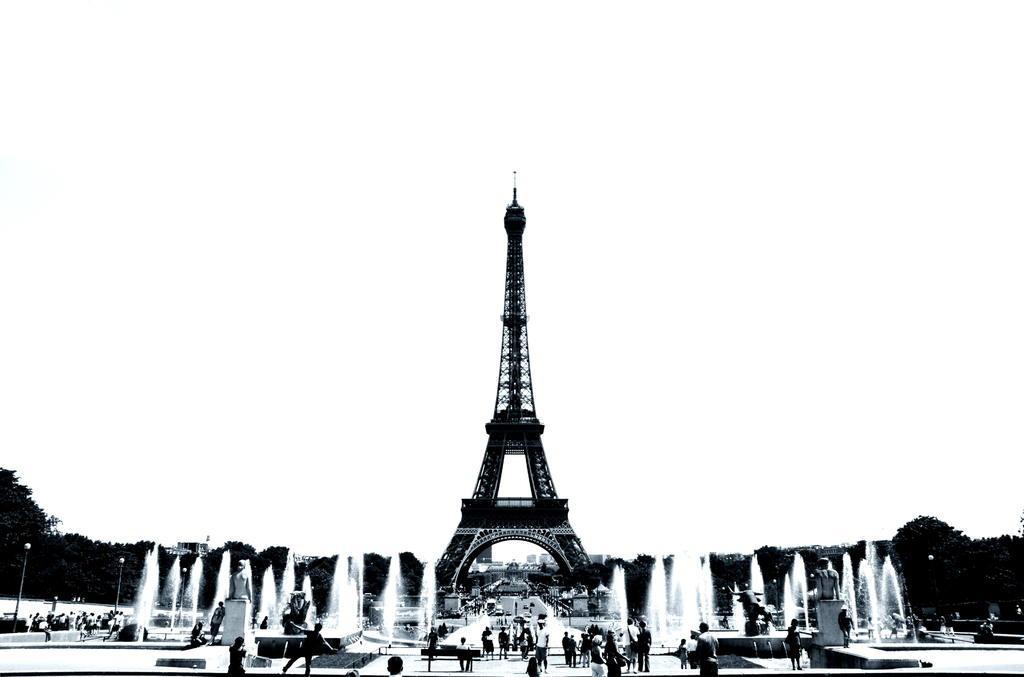Please provide a concise description of this image. In this image I can see people. There are fountains, trees and poles at the back. There is an eiffel tower in the center. This is a black and white image. 